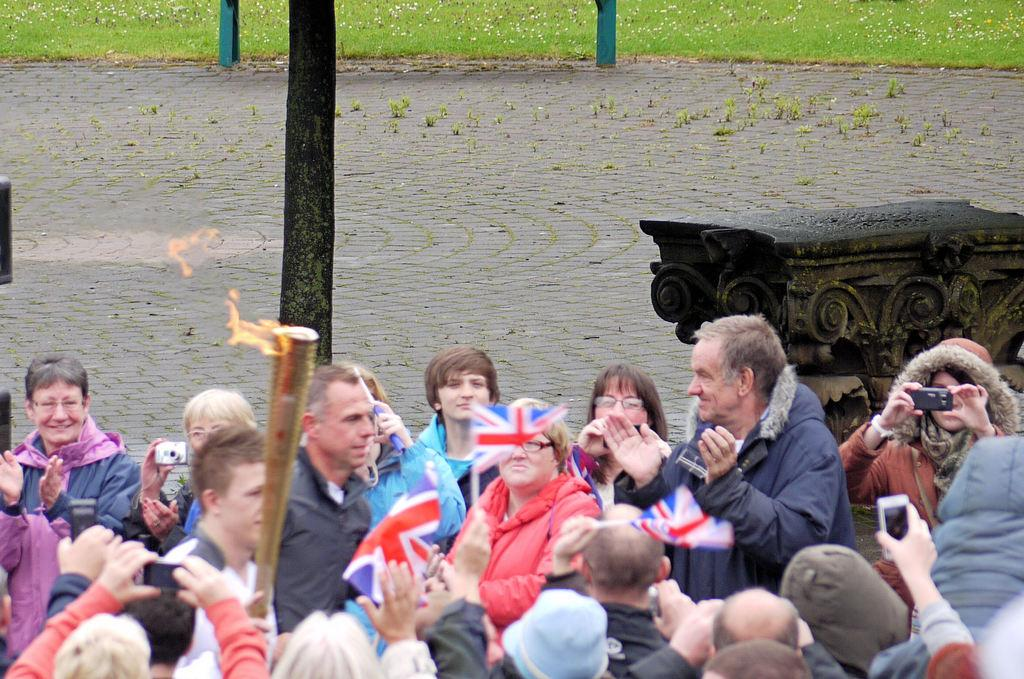Who or what can be seen at the bottom of the image? There are persons at the bottom of the image. What object is also present at the bottom of the image? There is a lamp at the bottom of the image. What can be seen in the background of the image? There is a tree, grass, and a pole in the background of the image. How many pairs of feet are visible in the image? There is no specific mention of feet in the provided facts, so it is impossible to determine the number of visible feet. What type of scissors can be seen cutting the tree in the image? There are no scissors present in the image, and the tree is not being cut. 